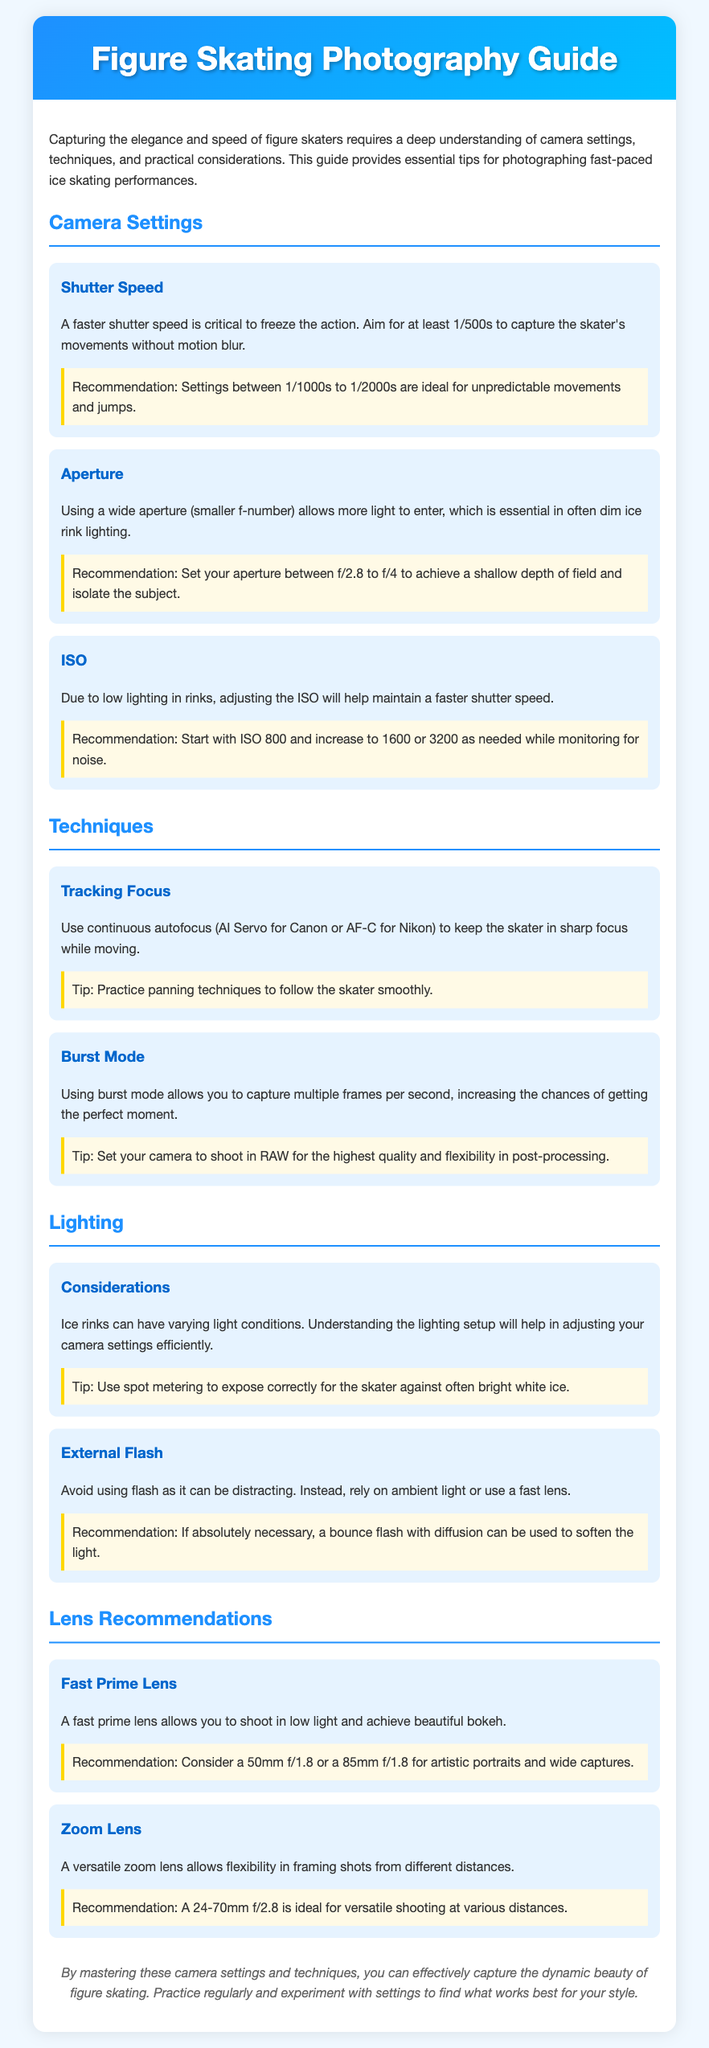What is the recommended shutter speed for capturing figure skaters? The document states that a faster shutter speed is critical to freeze the action, with a recommendation of between 1/1000s to 1/2000s for capturing unpredictable movements.
Answer: 1/1000s to 1/2000s What ISO setting should you start with in low lighting? The guide recommends starting with ISO 800 to maintain faster shutter speed in low light conditions typical of ice rinks.
Answer: ISO 800 What type of focus is suggested for tracking skaters? The note advises using continuous autofocus (AI Servo for Canon or AF-C for Nikon) to keep the skater in sharp focus.
Answer: Continuous autofocus What is recommended for capturing portraits of skaters? The document suggests using a 50mm f/1.8 or an 85mm f/1.8 fast prime lens for artistic portraits.
Answer: 50mm f/1.8 or 85mm f/1.8 What is the main consideration when using lighting in ice rinks? It emphasizes understanding the lighting setup of the rink to adjust camera settings correctly during varying light conditions.
Answer: Lighting setup Why should flash be avoided in figure skating photography? The guide advises against using flash because it can be distracting, recommending the use of ambient light instead.
Answer: Distracting What aperture setting is ideal for isolating the subject? The recommendation is to set the aperture between f/2.8 to f/4 to achieve a shallow depth of field.
Answer: f/2.8 to f/4 What photography technique increases the chances of capturing the perfect moment? The document notes that using burst mode allows capturing multiple frames per second for better timing on the perfect moment.
Answer: Burst mode 